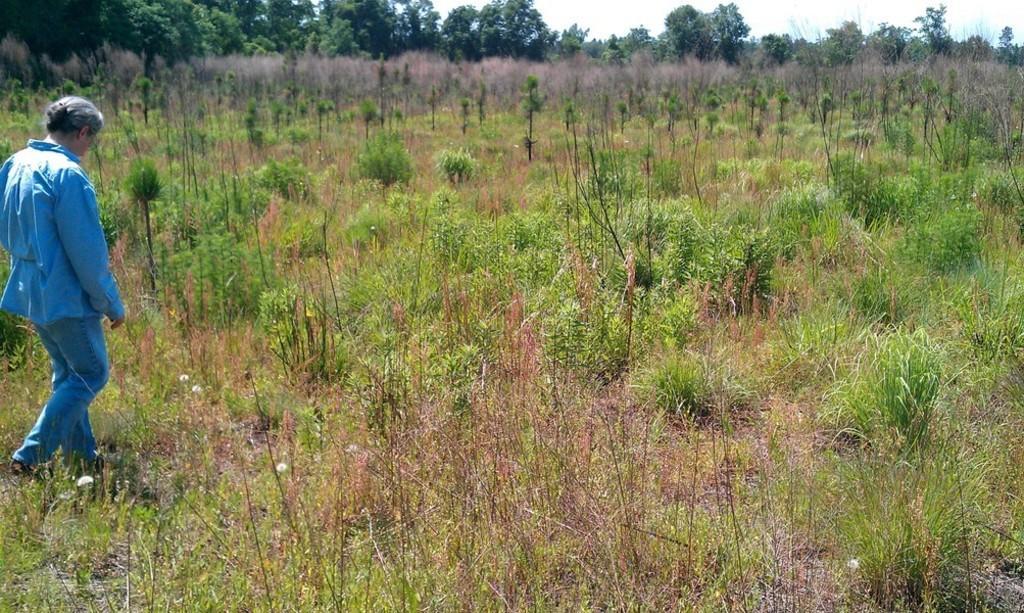Please provide a concise description of this image. In the picture I can see a person wearing a blue color dress is walking on the ground and is on the left side of the image. Here I can see the plants, grass, trees and the sky in the background. 